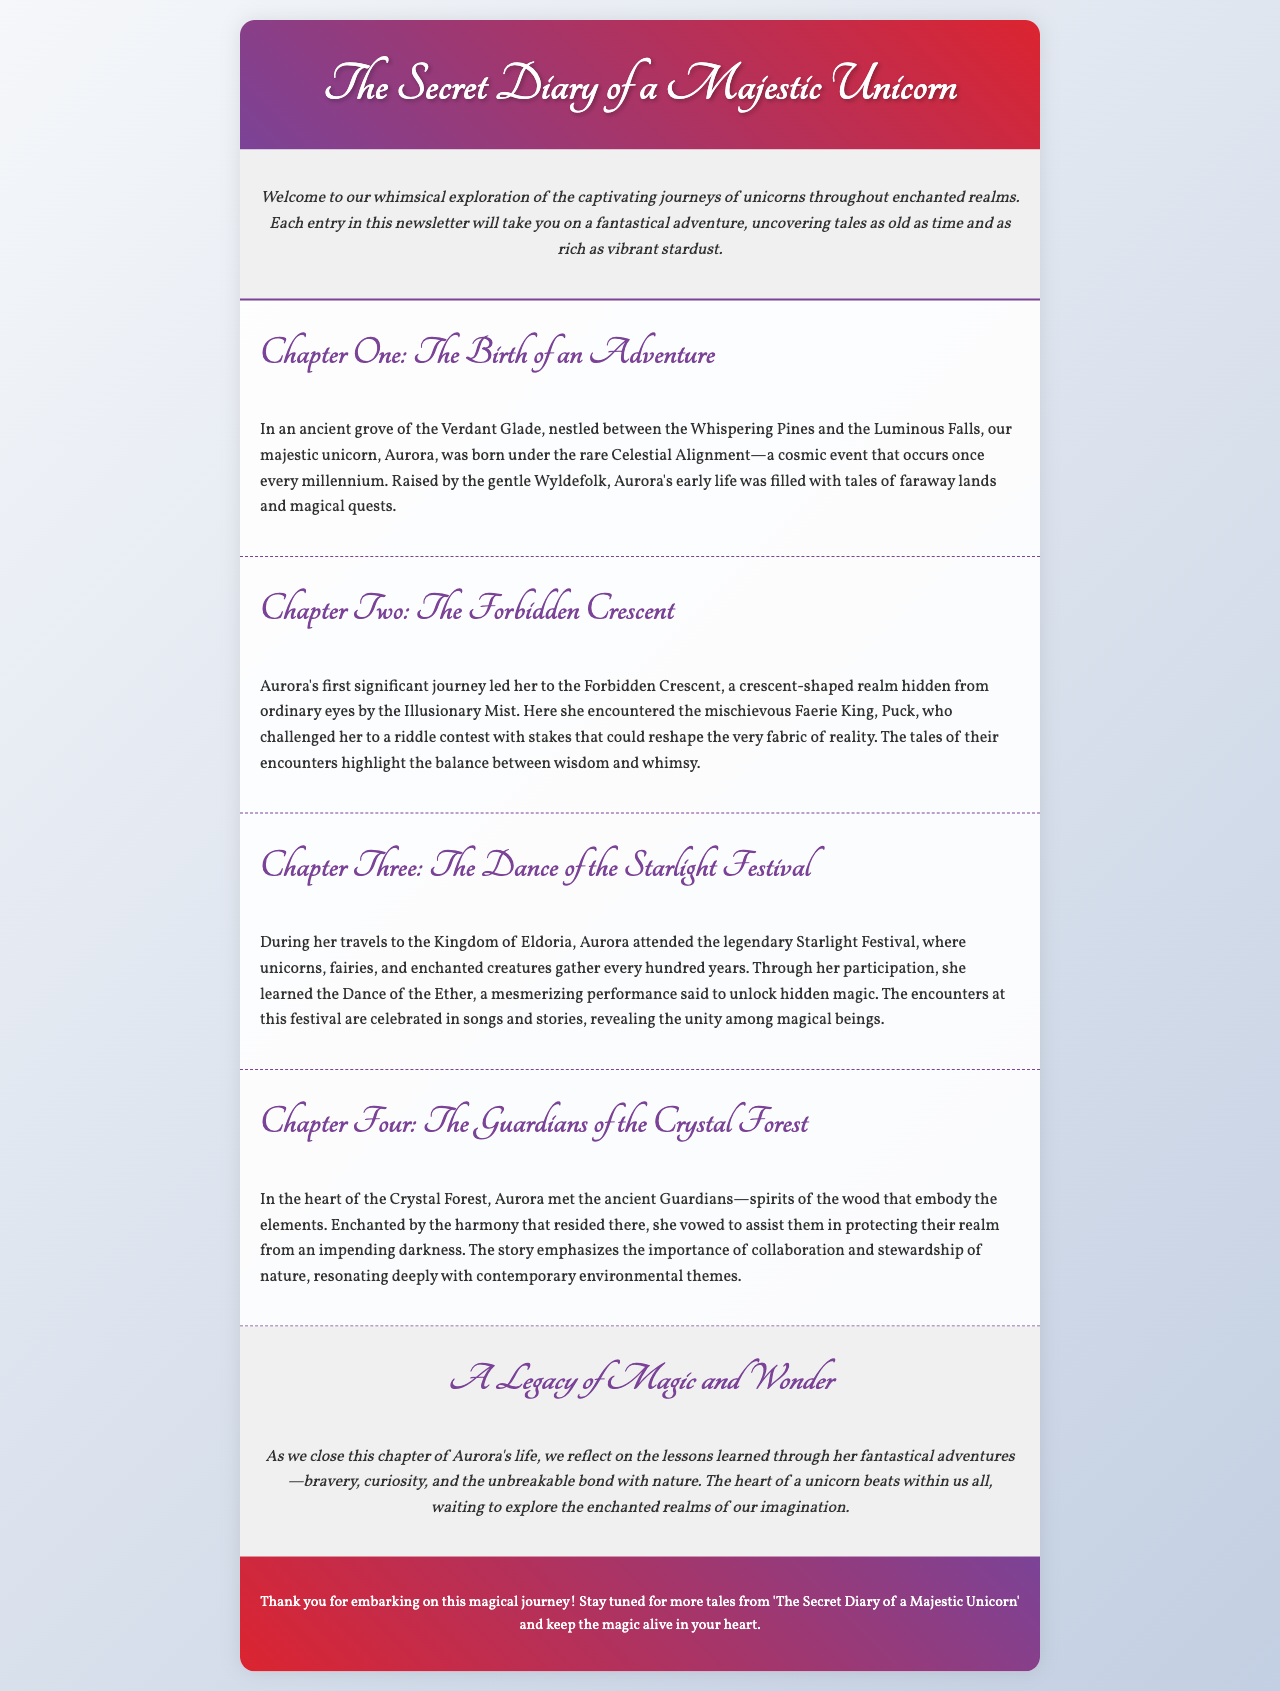What is the title of the newsletter? The title of the newsletter is prominently displayed at the top of the document, introducing the main subject.
Answer: The Secret Diary of a Majestic Unicorn Who is the main character of the story? The introduction of the main character is mentioned in Chapter One, where her birth and early life are described.
Answer: Aurora In which realm was Aurora born? The specific location of Aurora's birth is detailed in the first chapter, highlighting the magical environment.
Answer: Verdant Glade What unique cosmic event occurred when Aurora was born? The document mentions this significant event as a rare phenomenon linked to her birth.
Answer: Celestial Alignment Who challenged Aurora to a riddle contest? This character is introduced in Chapter Two, along with the whimsical challenge posed to Aurora.
Answer: Puck What did Aurora learn at the Starlight Festival? The chapter describes a specific skill or performance that Aurora participated in.
Answer: Dance of the Ether What did Aurora vow to do in the Crystal Forest? This is outlined in Chapter Four, where her commitment to the Guardians is emphasized.
Answer: Assist them Which theme resonates deeply with contemporary issues? The importance highlighted in Chapter Four connects with current global topics.
Answer: Environmental stewardship How often does the Starlight Festival occur? The frequency of this grand event involving magical beings is noted in Chapter Three.
Answer: Every hundred years 